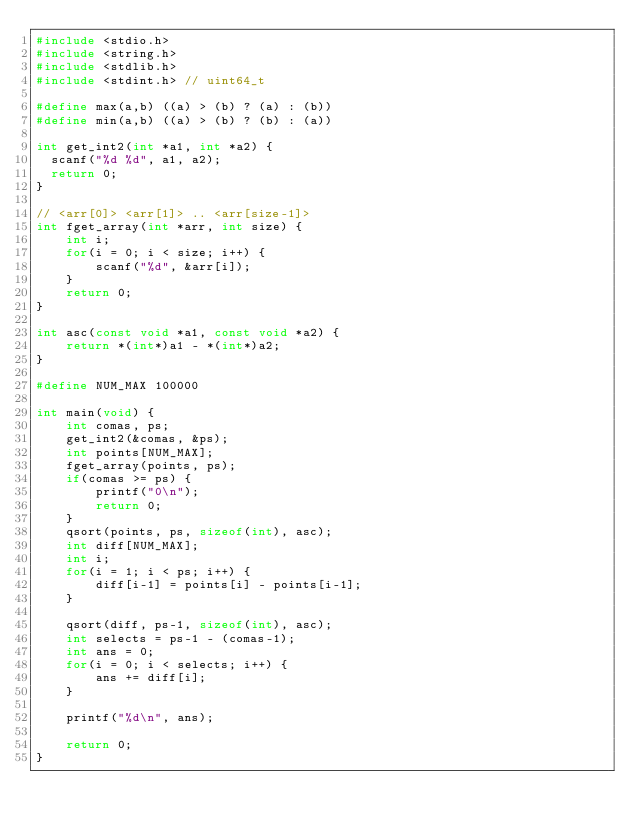Convert code to text. <code><loc_0><loc_0><loc_500><loc_500><_C_>#include <stdio.h>
#include <string.h>
#include <stdlib.h>
#include <stdint.h> // uint64_t

#define max(a,b) ((a) > (b) ? (a) : (b))
#define min(a,b) ((a) > (b) ? (b) : (a))

int get_int2(int *a1, int *a2) {
  scanf("%d %d", a1, a2);
  return 0;
}

// <arr[0]> <arr[1]> .. <arr[size-1]>
int fget_array(int *arr, int size) {
    int i;
    for(i = 0; i < size; i++) {
        scanf("%d", &arr[i]);
    }
    return 0;
}

int asc(const void *a1, const void *a2) {
    return *(int*)a1 - *(int*)a2;
}

#define NUM_MAX 100000

int main(void) {
    int comas, ps;
    get_int2(&comas, &ps);
    int points[NUM_MAX];
    fget_array(points, ps);
    if(comas >= ps) {
        printf("0\n");
        return 0;
    }
    qsort(points, ps, sizeof(int), asc);
    int diff[NUM_MAX];
    int i;
    for(i = 1; i < ps; i++) {
        diff[i-1] = points[i] - points[i-1];
    }

    qsort(diff, ps-1, sizeof(int), asc);
    int selects = ps-1 - (comas-1);
    int ans = 0;
    for(i = 0; i < selects; i++) {
        ans += diff[i];
    }

    printf("%d\n", ans);

    return 0;
}</code> 